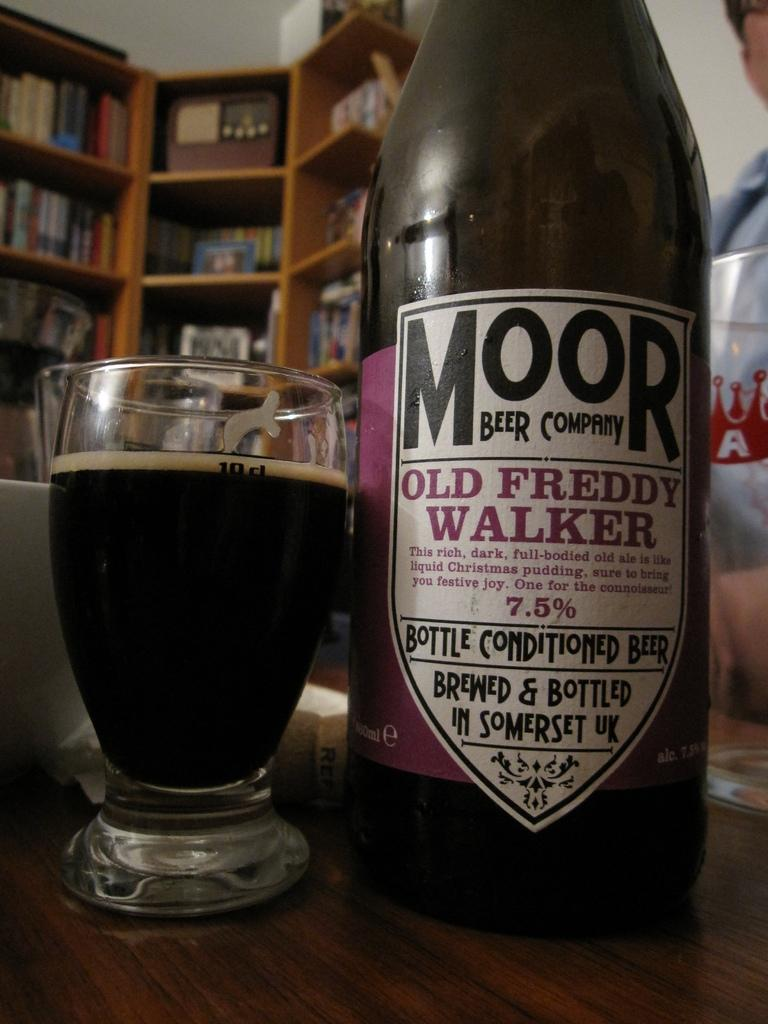What is on the table in the image? There is a bottle and a glass on the table in the image. What else can be seen in the image besides the table? There is a bookshelf visible in the image. What type of bomb is present in the image? There is no bomb present in the image; it only features a bottle, a glass, and a bookshelf. 